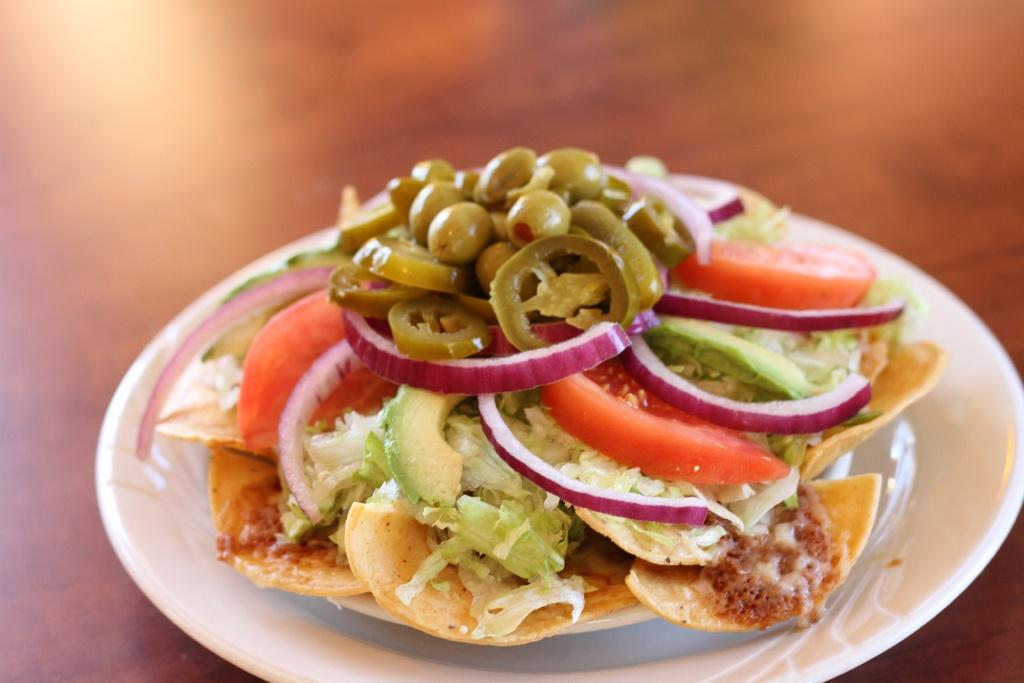What is present in the image that can be eaten? There are food items in the image. How are the food items arranged in the image? The food items are in a plate. What can be observed about the background of the image? The background of the image is blurred. What type of fan can be seen in the image? There is no fan present in the image. Can you hear the sound of a twig breaking in the image? There is no sound in the image, and no twig is visible. 